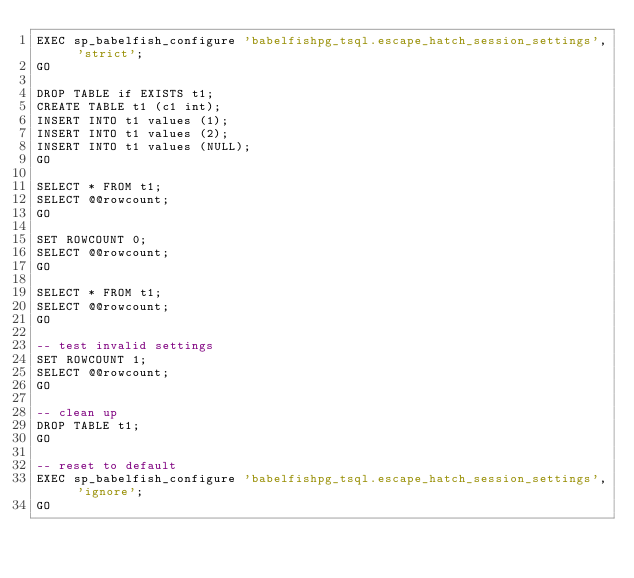<code> <loc_0><loc_0><loc_500><loc_500><_SQL_>EXEC sp_babelfish_configure 'babelfishpg_tsql.escape_hatch_session_settings', 'strict';
GO

DROP TABLE if EXISTS t1;
CREATE TABLE t1 (c1 int);
INSERT INTO t1 values (1);
INSERT INTO t1 values (2);
INSERT INTO t1 values (NULL);
GO

SELECT * FROM t1;
SELECT @@rowcount;
GO

SET ROWCOUNT 0;
SELECT @@rowcount;
GO

SELECT * FROM t1;
SELECT @@rowcount;
GO

-- test invalid settings
SET ROWCOUNT 1;
SELECT @@rowcount;
GO

-- clean up
DROP TABLE t1;
GO

-- reset to default
EXEC sp_babelfish_configure 'babelfishpg_tsql.escape_hatch_session_settings', 'ignore';
GO
</code> 